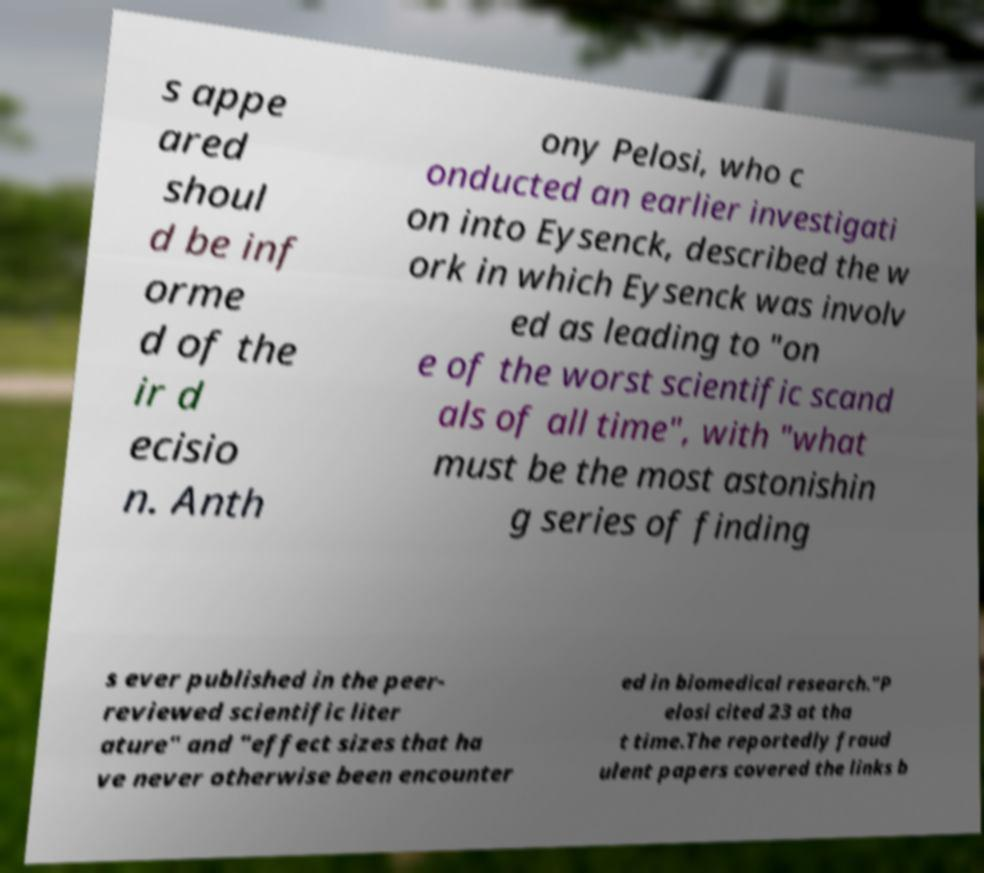Please identify and transcribe the text found in this image. s appe ared shoul d be inf orme d of the ir d ecisio n. Anth ony Pelosi, who c onducted an earlier investigati on into Eysenck, described the w ork in which Eysenck was involv ed as leading to "on e of the worst scientific scand als of all time", with "what must be the most astonishin g series of finding s ever published in the peer- reviewed scientific liter ature" and "effect sizes that ha ve never otherwise been encounter ed in biomedical research."P elosi cited 23 at tha t time.The reportedly fraud ulent papers covered the links b 